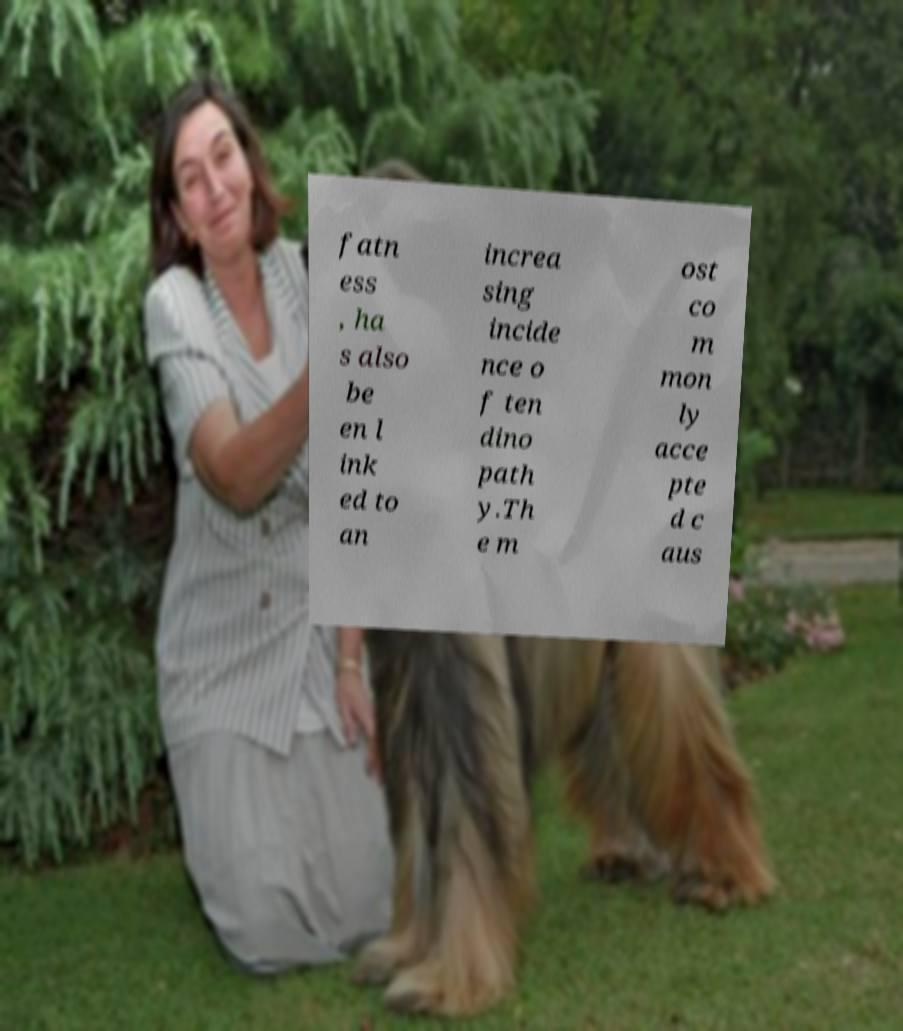There's text embedded in this image that I need extracted. Can you transcribe it verbatim? fatn ess , ha s also be en l ink ed to an increa sing incide nce o f ten dino path y.Th e m ost co m mon ly acce pte d c aus 